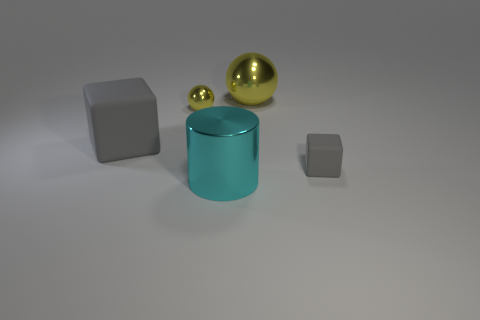There is a rubber cube that is in front of the big rubber block; is its color the same as the big matte thing?
Provide a succinct answer. Yes. Is the large matte block the same color as the small rubber object?
Give a very brief answer. Yes. What is the material of the small thing that is the same color as the large metal sphere?
Offer a very short reply. Metal. Is the size of the gray rubber thing to the right of the big gray cube the same as the gray matte thing that is behind the tiny matte cube?
Offer a terse response. No. How many other objects are the same material as the small yellow ball?
Offer a terse response. 2. Is the number of large gray matte blocks behind the tiny gray rubber thing greater than the number of large yellow things that are to the left of the large gray rubber cube?
Your answer should be very brief. Yes. What material is the yellow object that is to the right of the cyan cylinder?
Give a very brief answer. Metal. Does the small yellow metallic thing have the same shape as the large gray object?
Ensure brevity in your answer.  No. Is there any other thing of the same color as the small metallic thing?
Your answer should be very brief. Yes. What is the color of the large object that is the same shape as the small gray rubber object?
Your answer should be compact. Gray. 